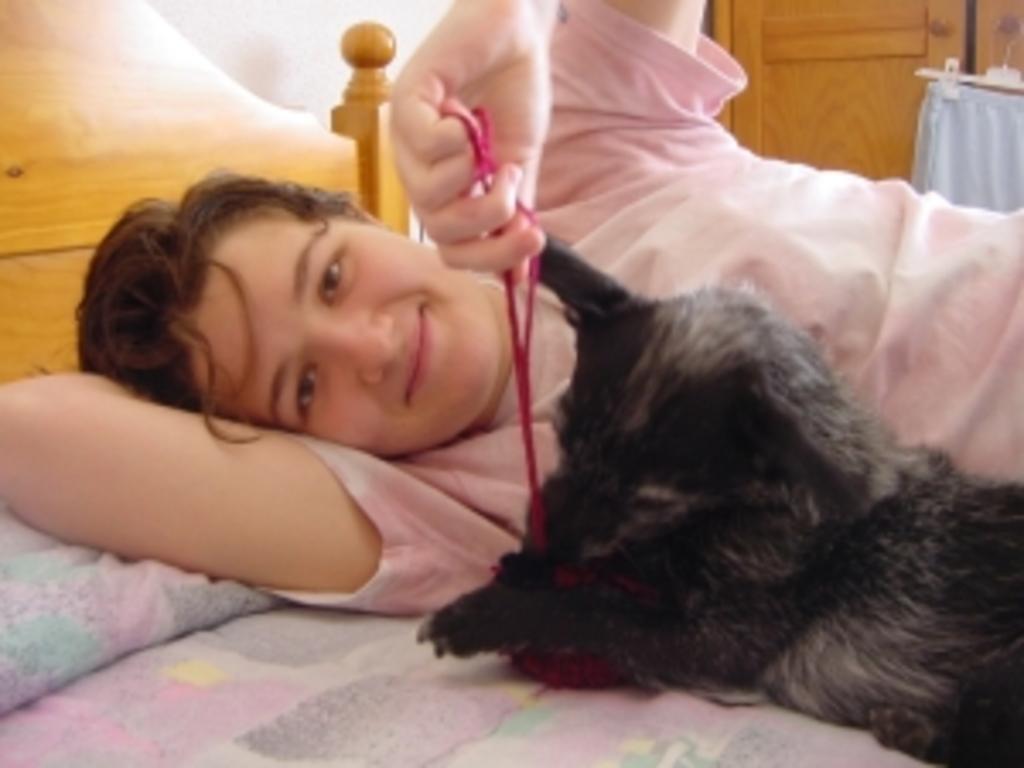In one or two sentences, can you explain what this image depicts? there is a man sleeping on a bed with a pet dog. 